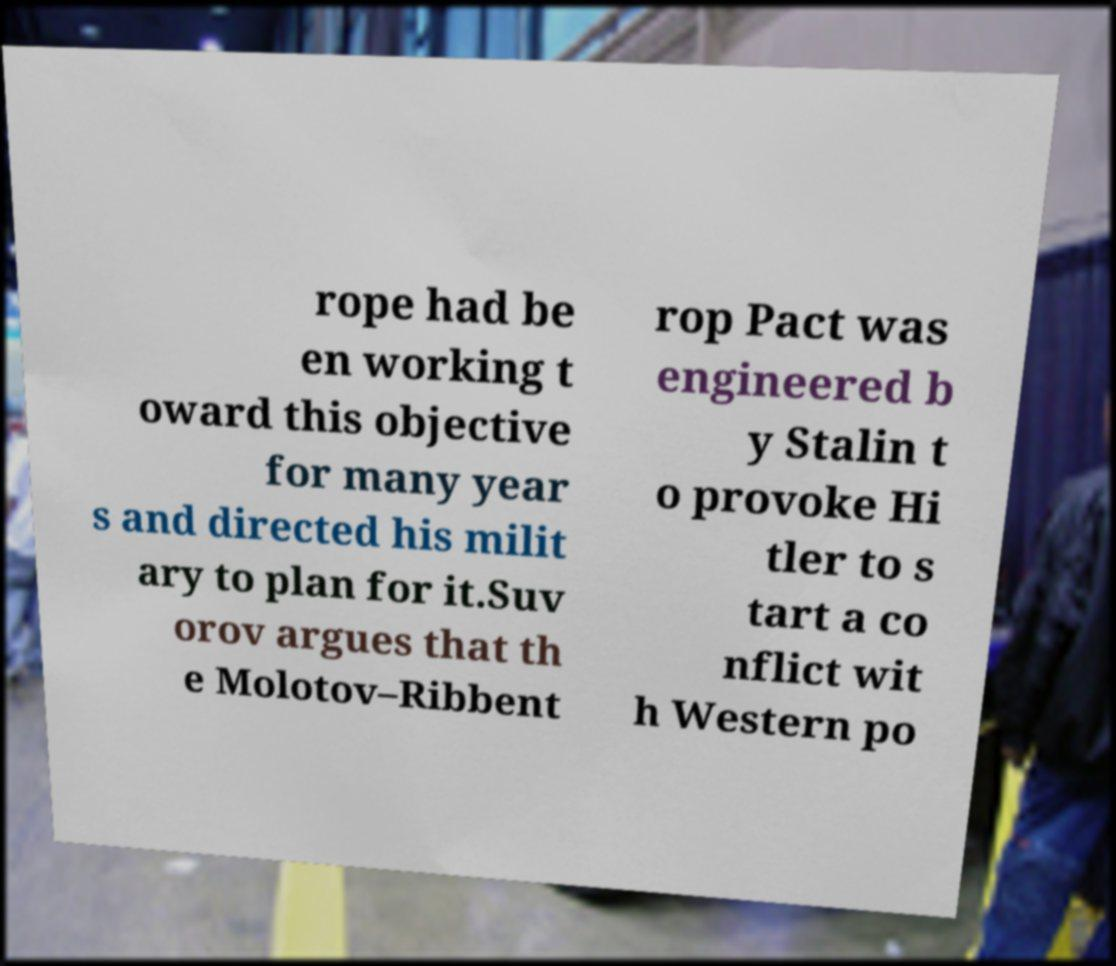What messages or text are displayed in this image? I need them in a readable, typed format. rope had be en working t oward this objective for many year s and directed his milit ary to plan for it.Suv orov argues that th e Molotov–Ribbent rop Pact was engineered b y Stalin t o provoke Hi tler to s tart a co nflict wit h Western po 